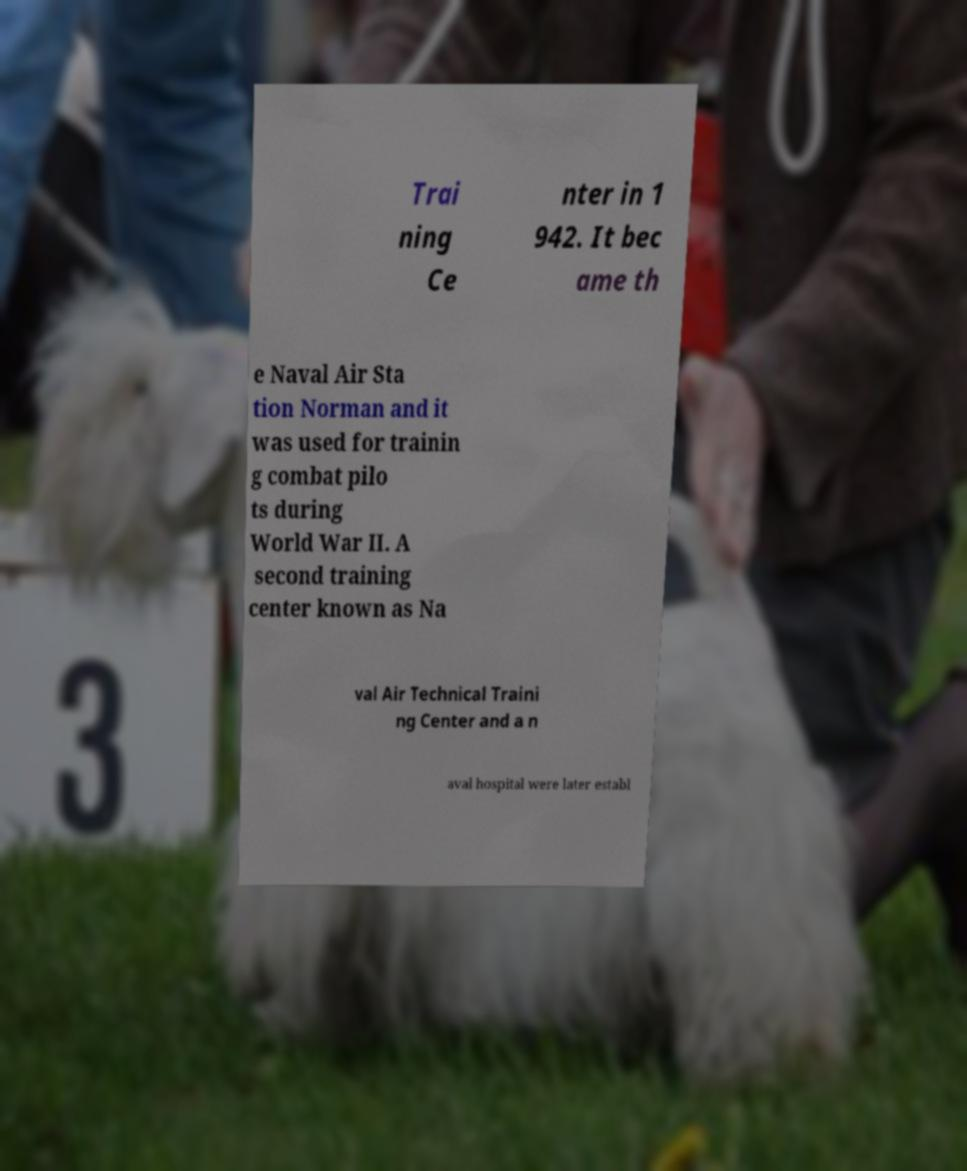Could you assist in decoding the text presented in this image and type it out clearly? Trai ning Ce nter in 1 942. It bec ame th e Naval Air Sta tion Norman and it was used for trainin g combat pilo ts during World War II. A second training center known as Na val Air Technical Traini ng Center and a n aval hospital were later establ 